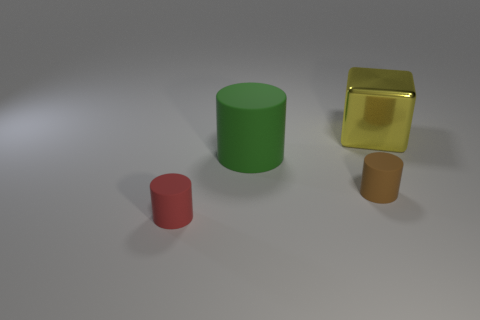Add 3 tiny brown objects. How many objects exist? 7 Subtract all cylinders. How many objects are left? 1 Subtract 0 purple blocks. How many objects are left? 4 Subtract all large yellow objects. Subtract all tiny green metal balls. How many objects are left? 3 Add 3 green matte cylinders. How many green matte cylinders are left? 4 Add 2 tiny brown matte objects. How many tiny brown matte objects exist? 3 